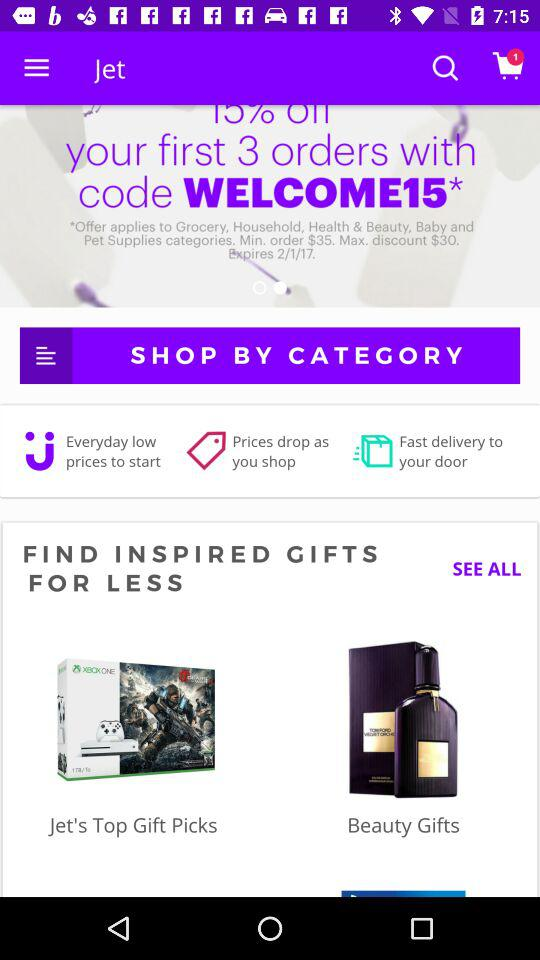What is the name of the application? The name of the application is "Jet". 